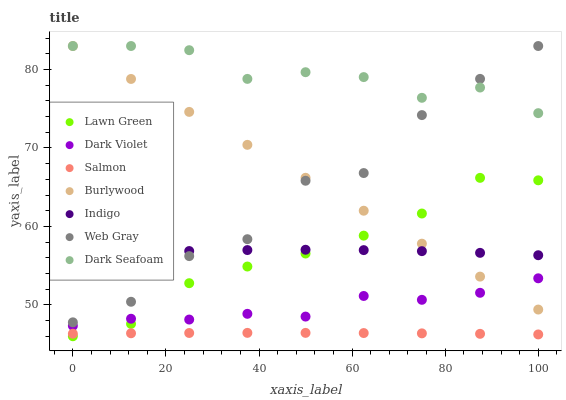Does Salmon have the minimum area under the curve?
Answer yes or no. Yes. Does Dark Seafoam have the maximum area under the curve?
Answer yes or no. Yes. Does Web Gray have the minimum area under the curve?
Answer yes or no. No. Does Web Gray have the maximum area under the curve?
Answer yes or no. No. Is Burlywood the smoothest?
Answer yes or no. Yes. Is Web Gray the roughest?
Answer yes or no. Yes. Is Indigo the smoothest?
Answer yes or no. No. Is Indigo the roughest?
Answer yes or no. No. Does Lawn Green have the lowest value?
Answer yes or no. Yes. Does Web Gray have the lowest value?
Answer yes or no. No. Does Dark Seafoam have the highest value?
Answer yes or no. Yes. Does Indigo have the highest value?
Answer yes or no. No. Is Salmon less than Indigo?
Answer yes or no. Yes. Is Indigo greater than Dark Violet?
Answer yes or no. Yes. Does Indigo intersect Web Gray?
Answer yes or no. Yes. Is Indigo less than Web Gray?
Answer yes or no. No. Is Indigo greater than Web Gray?
Answer yes or no. No. Does Salmon intersect Indigo?
Answer yes or no. No. 